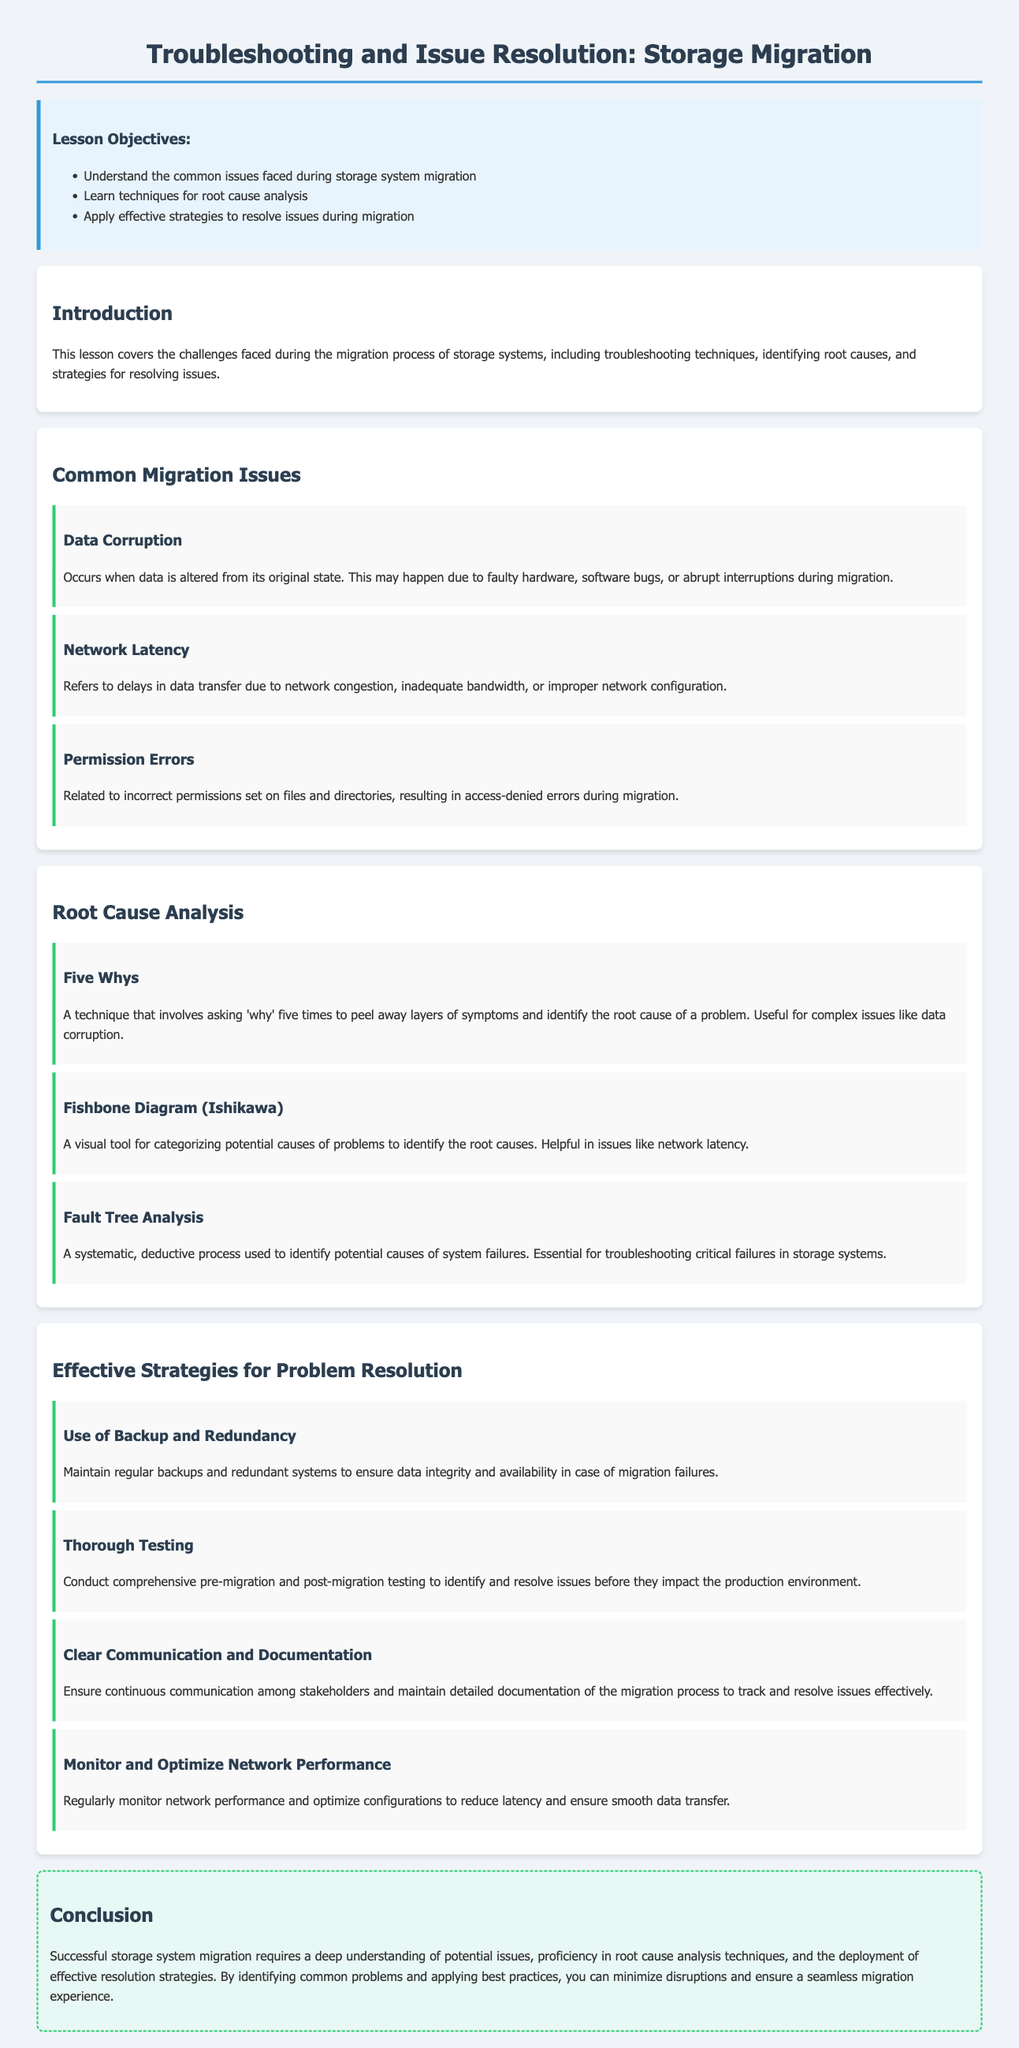What are the lesson objectives? The lesson objectives include understanding common issues, learning root cause analysis techniques, and applying effective strategies for resolution during migration.
Answer: Common issues, root cause analysis techniques, effective strategies for resolution What is data corruption? Data corruption occurs when data is altered from its original state due to hardware faults, software bugs, or interruptions.
Answer: Altered data What tool is used for categorizing potential causes of problems? The Fishbone Diagram, also known as the Ishikawa diagram, is mentioned as a visual tool for this purpose.
Answer: Fishbone Diagram What strategy emphasizes the importance of backup systems? The strategy of using backup and redundancy is highlighted to ensure data integrity.
Answer: Use of Backup and Redundancy How many methods for root cause analysis are mentioned? The document lists three methods for root cause analysis techniques during troubleshooting.
Answer: Three What technique involves asking "why" five times? The Five Whys technique is the method that involves asking "why" repeatedly to identify root causes.
Answer: Five Whys What should be monitored to reduce latency? Network performance should be monitored and optimized to reduce latency effectively.
Answer: Network performance What is the main focus of the introduction? The introduction covers the challenges faced during storage system migration, focusing on troubleshooting and issue resolution.
Answer: Challenges during migration What is one of the key components of effective communication in migrations? Clear communication and documentation among stakeholders are emphasized as crucial for success in migration efforts.
Answer: Clear communication and documentation 